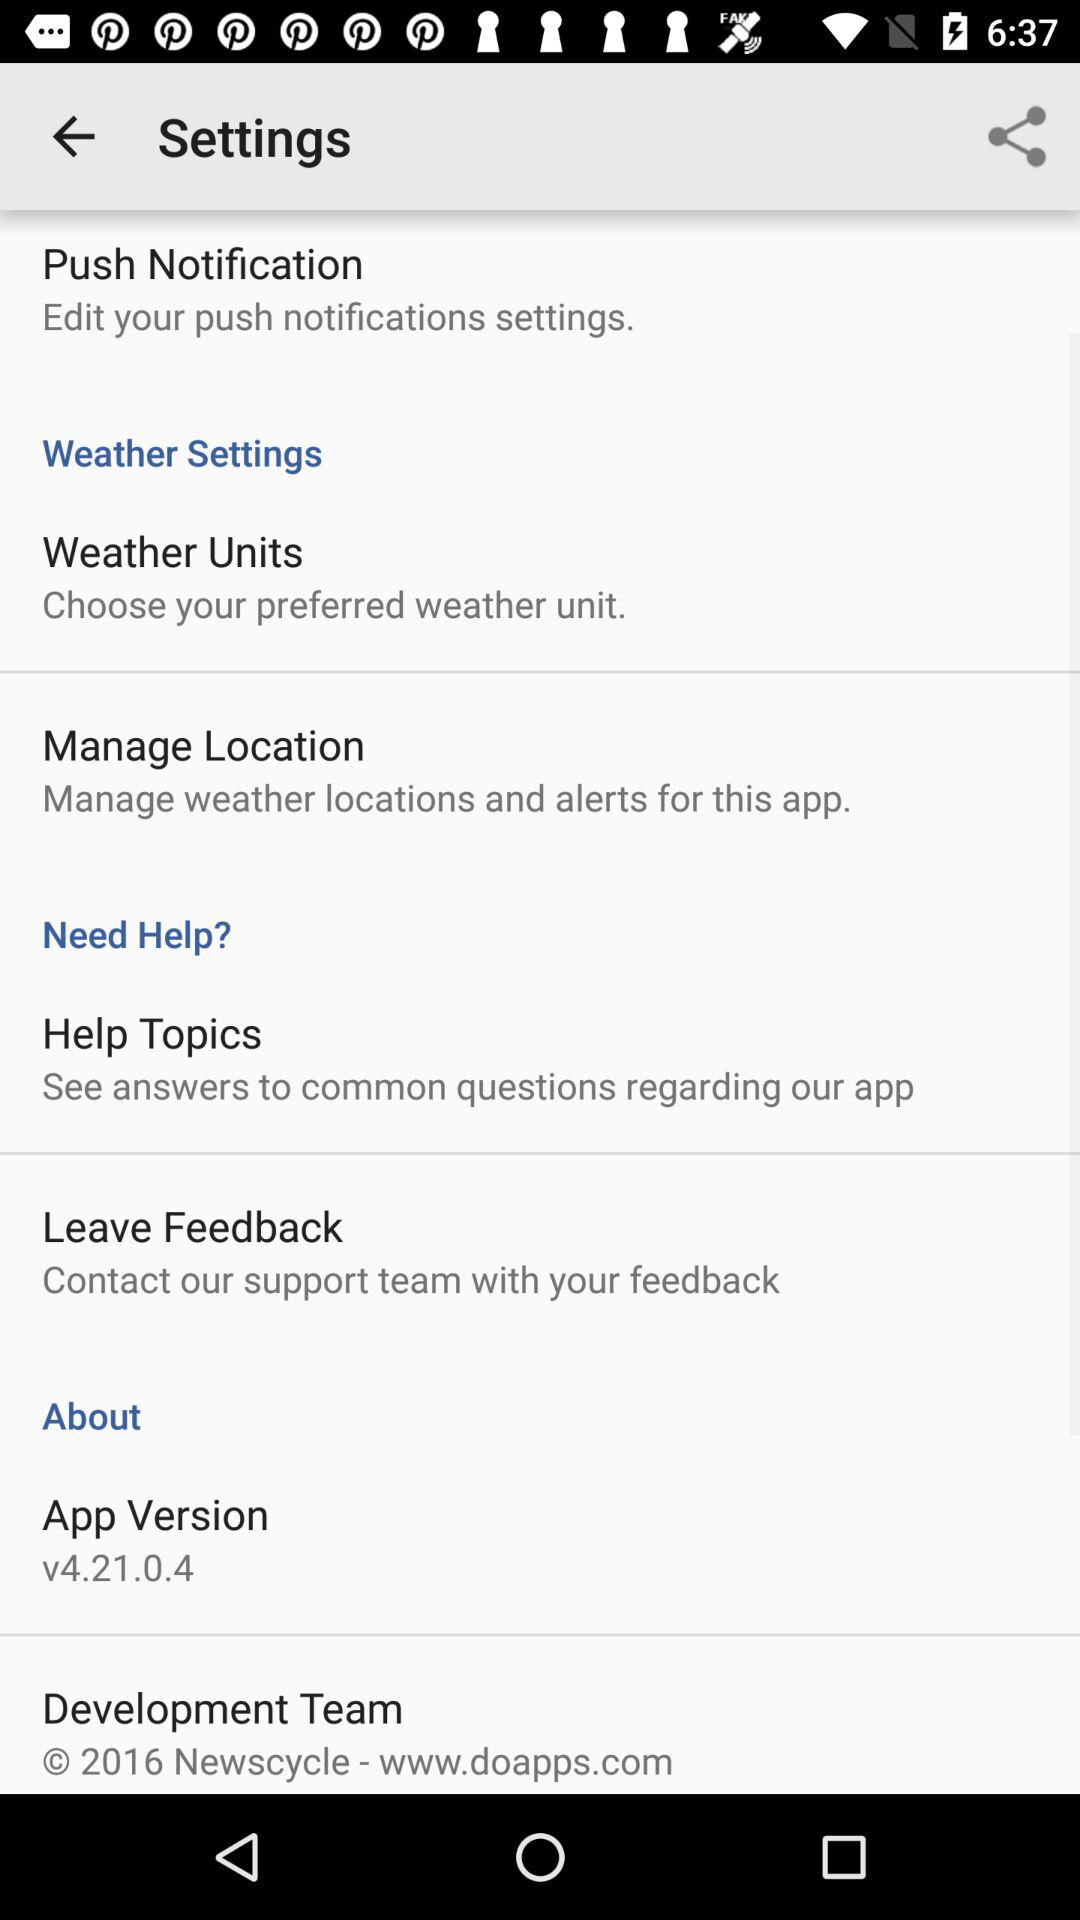What is the app version? The app version is v4.21.0.4. 